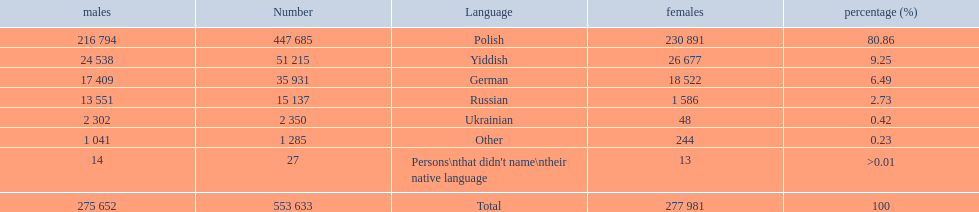Which is the least spoken language? Ukrainian. 